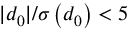<formula> <loc_0><loc_0><loc_500><loc_500>| d _ { 0 } | / \sigma \left ( d _ { 0 } \right ) < 5</formula> 